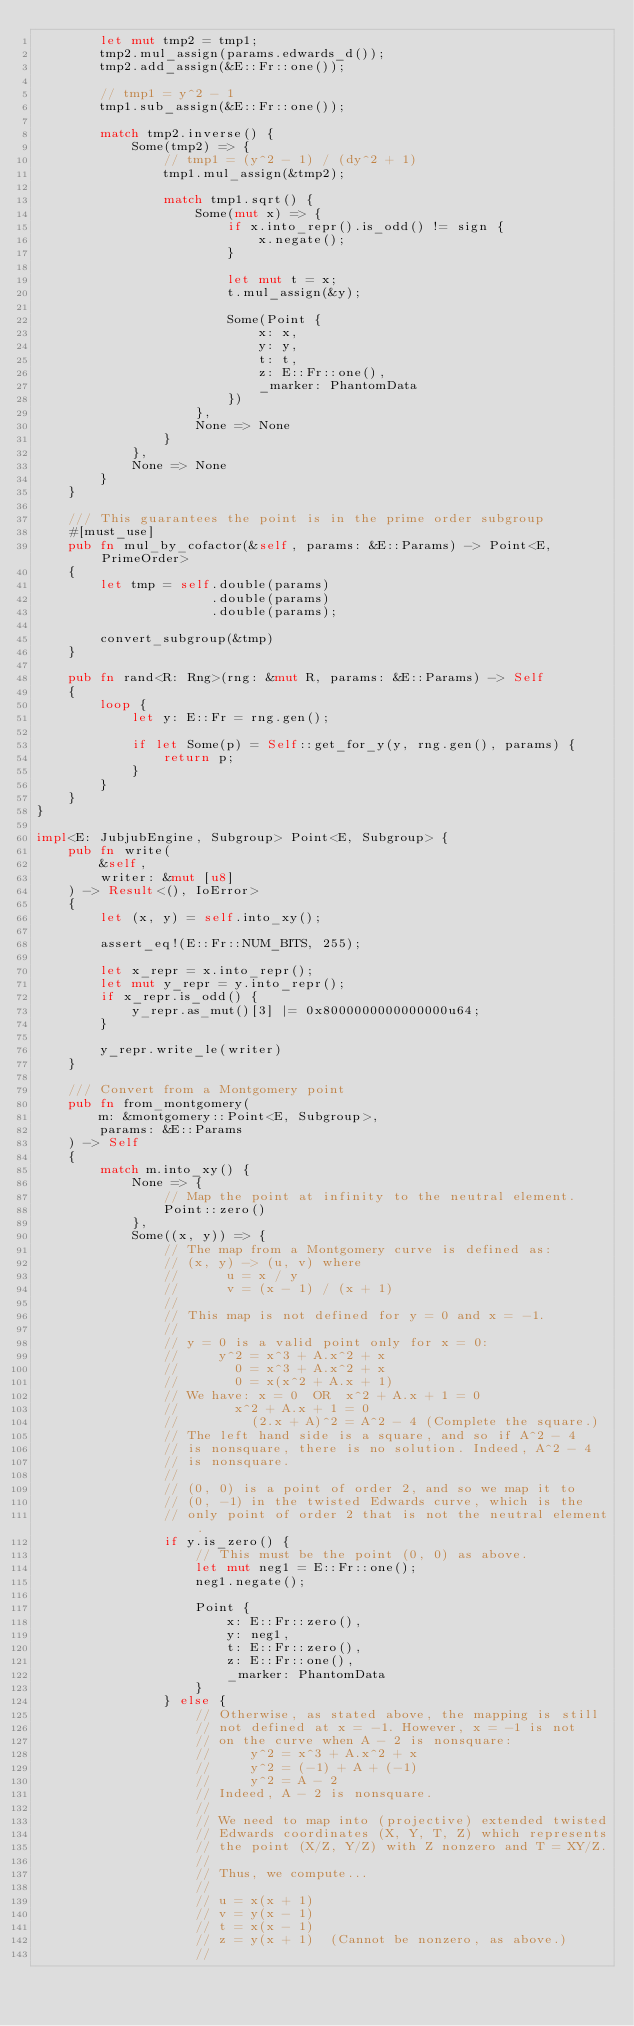<code> <loc_0><loc_0><loc_500><loc_500><_Rust_>        let mut tmp2 = tmp1;
        tmp2.mul_assign(params.edwards_d());
        tmp2.add_assign(&E::Fr::one());

        // tmp1 = y^2 - 1
        tmp1.sub_assign(&E::Fr::one());

        match tmp2.inverse() {
            Some(tmp2) => {
                // tmp1 = (y^2 - 1) / (dy^2 + 1)
                tmp1.mul_assign(&tmp2);

                match tmp1.sqrt() {
                    Some(mut x) => {
                        if x.into_repr().is_odd() != sign {
                            x.negate();
                        }

                        let mut t = x;
                        t.mul_assign(&y);

                        Some(Point {
                            x: x,
                            y: y,
                            t: t,
                            z: E::Fr::one(),
                            _marker: PhantomData
                        })
                    },
                    None => None
                }
            },
            None => None
        }
    }

    /// This guarantees the point is in the prime order subgroup
    #[must_use]
    pub fn mul_by_cofactor(&self, params: &E::Params) -> Point<E, PrimeOrder>
    {
        let tmp = self.double(params)
                      .double(params)
                      .double(params);

        convert_subgroup(&tmp)
    }

    pub fn rand<R: Rng>(rng: &mut R, params: &E::Params) -> Self
    {
        loop {
            let y: E::Fr = rng.gen();

            if let Some(p) = Self::get_for_y(y, rng.gen(), params) {
                return p;
            }
        }
    }
}

impl<E: JubjubEngine, Subgroup> Point<E, Subgroup> {
    pub fn write(
        &self,
        writer: &mut [u8]
    ) -> Result<(), IoError>
    {
        let (x, y) = self.into_xy();

        assert_eq!(E::Fr::NUM_BITS, 255);

        let x_repr = x.into_repr();
        let mut y_repr = y.into_repr();
        if x_repr.is_odd() {
            y_repr.as_mut()[3] |= 0x8000000000000000u64;
        }

        y_repr.write_le(writer)
    }

    /// Convert from a Montgomery point
    pub fn from_montgomery(
        m: &montgomery::Point<E, Subgroup>,
        params: &E::Params
    ) -> Self
    {
        match m.into_xy() {
            None => {
                // Map the point at infinity to the neutral element.
                Point::zero()
            },
            Some((x, y)) => {
                // The map from a Montgomery curve is defined as:
                // (x, y) -> (u, v) where
                //      u = x / y
                //      v = (x - 1) / (x + 1)
                //
                // This map is not defined for y = 0 and x = -1.
                //
                // y = 0 is a valid point only for x = 0:
                //     y^2 = x^3 + A.x^2 + x
                //       0 = x^3 + A.x^2 + x
                //       0 = x(x^2 + A.x + 1)
                // We have: x = 0  OR  x^2 + A.x + 1 = 0
                //       x^2 + A.x + 1 = 0
                //         (2.x + A)^2 = A^2 - 4 (Complete the square.)
                // The left hand side is a square, and so if A^2 - 4
                // is nonsquare, there is no solution. Indeed, A^2 - 4
                // is nonsquare.
                //
                // (0, 0) is a point of order 2, and so we map it to
                // (0, -1) in the twisted Edwards curve, which is the
                // only point of order 2 that is not the neutral element.
                if y.is_zero() {
                    // This must be the point (0, 0) as above.
                    let mut neg1 = E::Fr::one();
                    neg1.negate();

                    Point {
                        x: E::Fr::zero(),
                        y: neg1,
                        t: E::Fr::zero(),
                        z: E::Fr::one(),
                        _marker: PhantomData
                    }
                } else {
                    // Otherwise, as stated above, the mapping is still
                    // not defined at x = -1. However, x = -1 is not
                    // on the curve when A - 2 is nonsquare:
                    //     y^2 = x^3 + A.x^2 + x
                    //     y^2 = (-1) + A + (-1)
                    //     y^2 = A - 2
                    // Indeed, A - 2 is nonsquare.
                    //
                    // We need to map into (projective) extended twisted
                    // Edwards coordinates (X, Y, T, Z) which represents
                    // the point (X/Z, Y/Z) with Z nonzero and T = XY/Z.
                    //
                    // Thus, we compute...
                    //
                    // u = x(x + 1)
                    // v = y(x - 1)
                    // t = x(x - 1)
                    // z = y(x + 1)  (Cannot be nonzero, as above.)
                    //</code> 